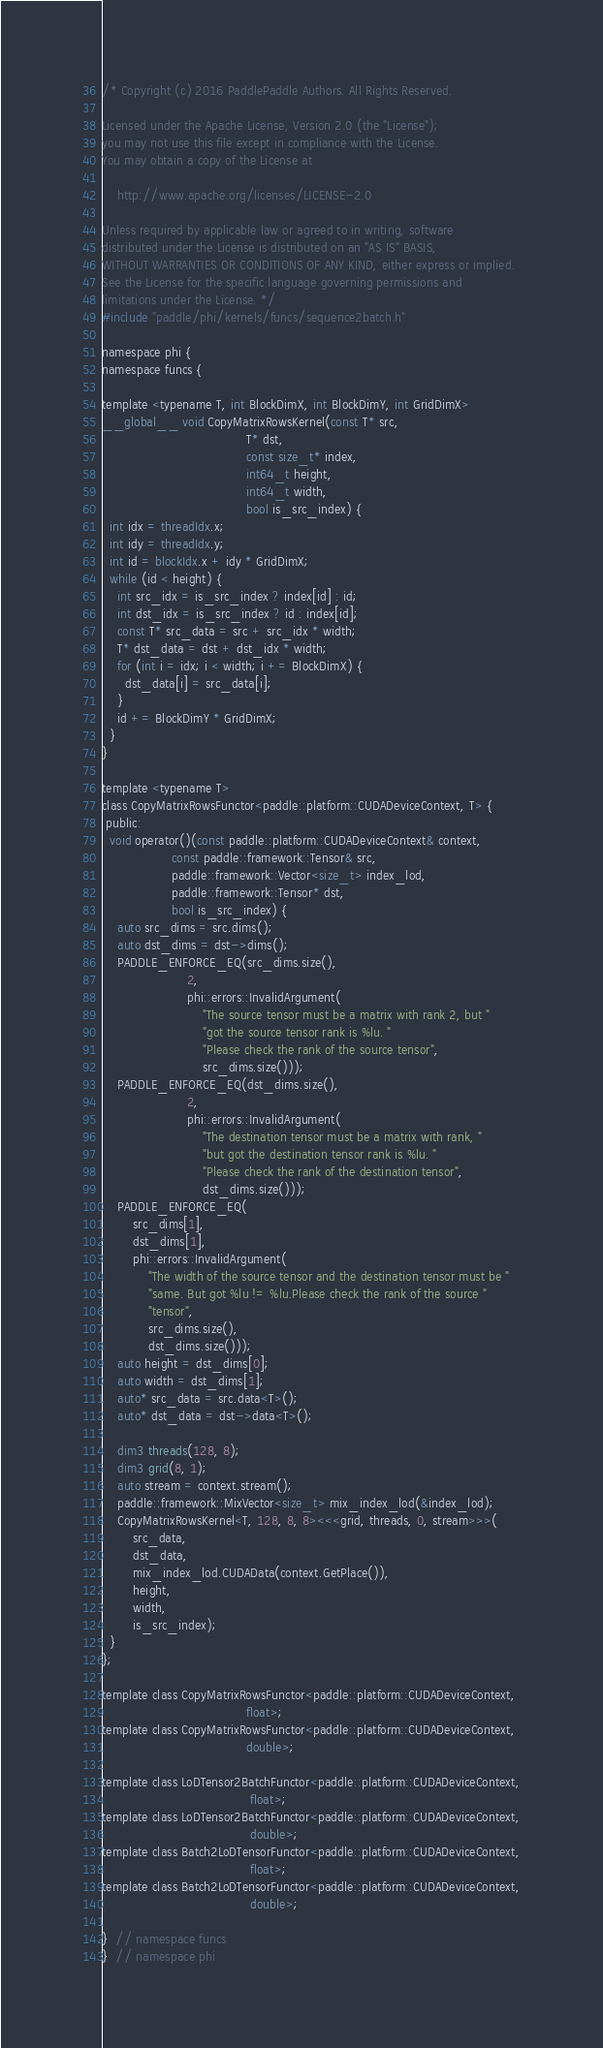Convert code to text. <code><loc_0><loc_0><loc_500><loc_500><_Cuda_>/* Copyright (c) 2016 PaddlePaddle Authors. All Rights Reserved.

Licensed under the Apache License, Version 2.0 (the "License");
you may not use this file except in compliance with the License.
You may obtain a copy of the License at

    http://www.apache.org/licenses/LICENSE-2.0

Unless required by applicable law or agreed to in writing, software
distributed under the License is distributed on an "AS IS" BASIS,
WITHOUT WARRANTIES OR CONDITIONS OF ANY KIND, either express or implied.
See the License for the specific language governing permissions and
limitations under the License. */
#include "paddle/phi/kernels/funcs/sequence2batch.h"

namespace phi {
namespace funcs {

template <typename T, int BlockDimX, int BlockDimY, int GridDimX>
__global__ void CopyMatrixRowsKernel(const T* src,
                                     T* dst,
                                     const size_t* index,
                                     int64_t height,
                                     int64_t width,
                                     bool is_src_index) {
  int idx = threadIdx.x;
  int idy = threadIdx.y;
  int id = blockIdx.x + idy * GridDimX;
  while (id < height) {
    int src_idx = is_src_index ? index[id] : id;
    int dst_idx = is_src_index ? id : index[id];
    const T* src_data = src + src_idx * width;
    T* dst_data = dst + dst_idx * width;
    for (int i = idx; i < width; i += BlockDimX) {
      dst_data[i] = src_data[i];
    }
    id += BlockDimY * GridDimX;
  }
}

template <typename T>
class CopyMatrixRowsFunctor<paddle::platform::CUDADeviceContext, T> {
 public:
  void operator()(const paddle::platform::CUDADeviceContext& context,
                  const paddle::framework::Tensor& src,
                  paddle::framework::Vector<size_t> index_lod,
                  paddle::framework::Tensor* dst,
                  bool is_src_index) {
    auto src_dims = src.dims();
    auto dst_dims = dst->dims();
    PADDLE_ENFORCE_EQ(src_dims.size(),
                      2,
                      phi::errors::InvalidArgument(
                          "The source tensor must be a matrix with rank 2, but "
                          "got the source tensor rank is %lu. "
                          "Please check the rank of the source tensor",
                          src_dims.size()));
    PADDLE_ENFORCE_EQ(dst_dims.size(),
                      2,
                      phi::errors::InvalidArgument(
                          "The destination tensor must be a matrix with rank, "
                          "but got the destination tensor rank is %lu. "
                          "Please check the rank of the destination tensor",
                          dst_dims.size()));
    PADDLE_ENFORCE_EQ(
        src_dims[1],
        dst_dims[1],
        phi::errors::InvalidArgument(
            "The width of the source tensor and the destination tensor must be "
            "same. But got %lu != %lu.Please check the rank of the source "
            "tensor",
            src_dims.size(),
            dst_dims.size()));
    auto height = dst_dims[0];
    auto width = dst_dims[1];
    auto* src_data = src.data<T>();
    auto* dst_data = dst->data<T>();

    dim3 threads(128, 8);
    dim3 grid(8, 1);
    auto stream = context.stream();
    paddle::framework::MixVector<size_t> mix_index_lod(&index_lod);
    CopyMatrixRowsKernel<T, 128, 8, 8><<<grid, threads, 0, stream>>>(
        src_data,
        dst_data,
        mix_index_lod.CUDAData(context.GetPlace()),
        height,
        width,
        is_src_index);
  }
};

template class CopyMatrixRowsFunctor<paddle::platform::CUDADeviceContext,
                                     float>;
template class CopyMatrixRowsFunctor<paddle::platform::CUDADeviceContext,
                                     double>;

template class LoDTensor2BatchFunctor<paddle::platform::CUDADeviceContext,
                                      float>;
template class LoDTensor2BatchFunctor<paddle::platform::CUDADeviceContext,
                                      double>;
template class Batch2LoDTensorFunctor<paddle::platform::CUDADeviceContext,
                                      float>;
template class Batch2LoDTensorFunctor<paddle::platform::CUDADeviceContext,
                                      double>;

}  // namespace funcs
}  // namespace phi
</code> 